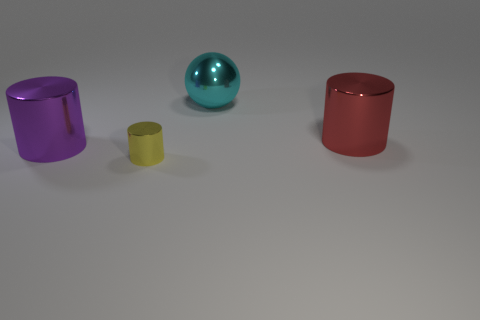Add 1 cyan balls. How many objects exist? 5 Subtract all cylinders. How many objects are left? 1 Subtract 0 cyan blocks. How many objects are left? 4 Subtract all gray rubber cylinders. Subtract all yellow things. How many objects are left? 3 Add 4 purple cylinders. How many purple cylinders are left? 5 Add 1 red shiny cylinders. How many red shiny cylinders exist? 2 